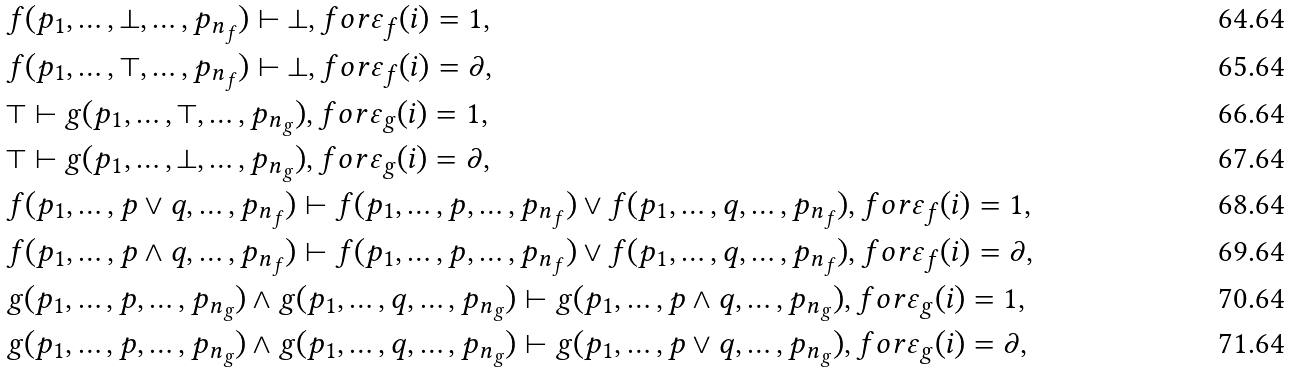<formula> <loc_0><loc_0><loc_500><loc_500>& f ( p _ { 1 } , \dots , \bot , \dots , p _ { n _ { f } } ) \vdash \bot , f o r \varepsilon _ { f } ( i ) = 1 , \\ & f ( p _ { 1 } , \dots , \top , \dots , p _ { n _ { f } } ) \vdash \bot , f o r \varepsilon _ { f } ( i ) = \partial , \\ & \top \vdash g ( p _ { 1 } , \dots , \top , \dots , p _ { n _ { g } } ) , f o r \varepsilon _ { g } ( i ) = 1 , \\ & \top \vdash g ( p _ { 1 } , \dots , \bot , \dots , p _ { n _ { g } } ) , f o r \varepsilon _ { g } ( i ) = \partial , \\ & f ( p _ { 1 } , \dots , p \vee q , \dots , p _ { n _ { f } } ) \vdash f ( p _ { 1 } , \dots , p , \dots , p _ { n _ { f } } ) \vee f ( p _ { 1 } , \dots , q , \dots , p _ { n _ { f } } ) , f o r \varepsilon _ { f } ( i ) = 1 , \\ & f ( p _ { 1 } , \dots , p \wedge q , \dots , p _ { n _ { f } } ) \vdash f ( p _ { 1 } , \dots , p , \dots , p _ { n _ { f } } ) \vee f ( p _ { 1 } , \dots , q , \dots , p _ { n _ { f } } ) , f o r \varepsilon _ { f } ( i ) = \partial , \\ & g ( p _ { 1 } , \dots , p , \dots , p _ { n _ { g } } ) \wedge g ( p _ { 1 } , \dots , q , \dots , p _ { n _ { g } } ) \vdash g ( p _ { 1 } , \dots , p \wedge q , \dots , p _ { n _ { g } } ) , f o r \varepsilon _ { g } ( i ) = 1 , \\ & g ( p _ { 1 } , \dots , p , \dots , p _ { n _ { g } } ) \wedge g ( p _ { 1 } , \dots , q , \dots , p _ { n _ { g } } ) \vdash g ( p _ { 1 } , \dots , p \vee q , \dots , p _ { n _ { g } } ) , f o r \varepsilon _ { g } ( i ) = \partial ,</formula> 